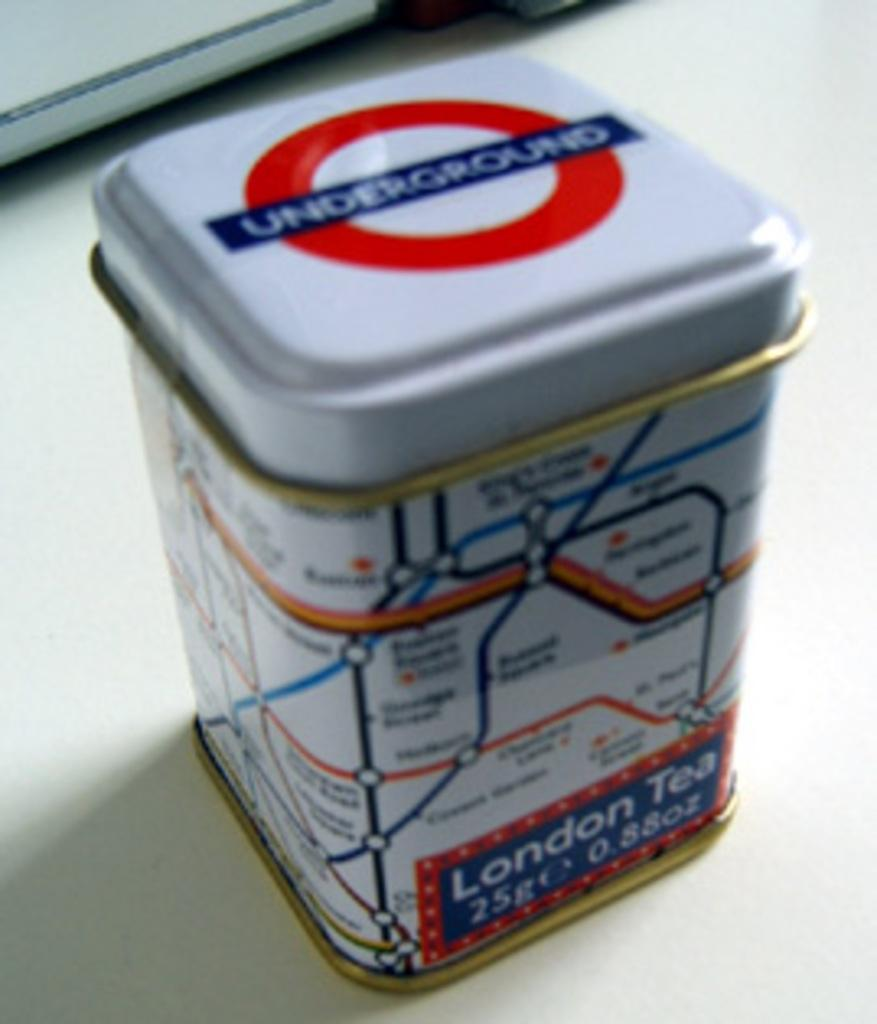<image>
Create a compact narrative representing the image presented. London Tea sometimes comes in a tin with UNDERGROUND written on the lid. 